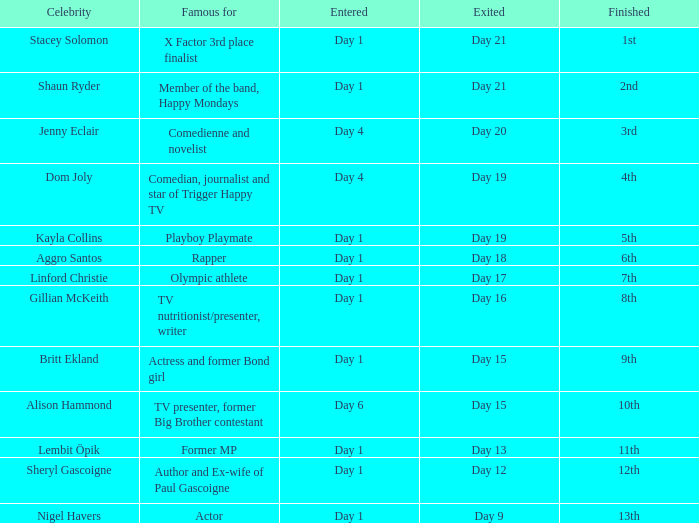What position did the celebrity finish that entered on day 1 and exited on day 15? 9th. 